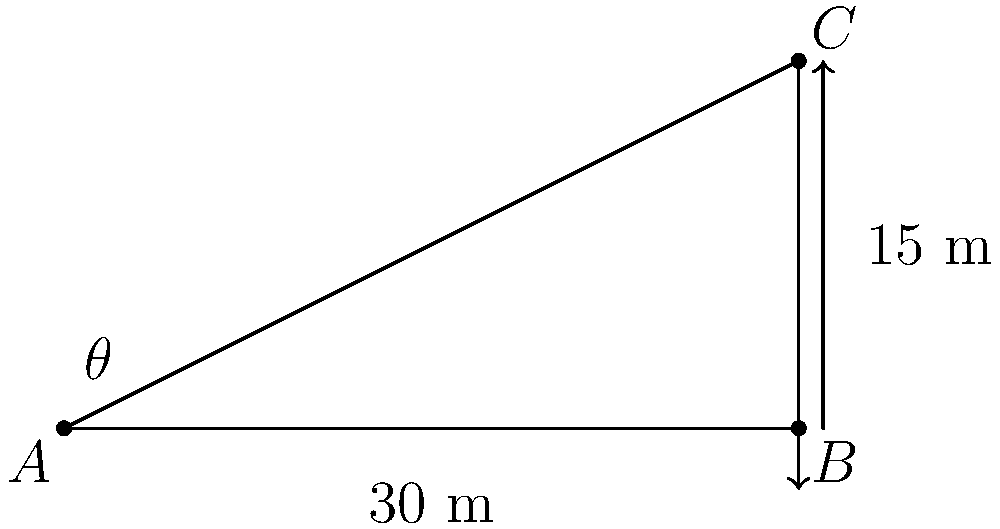As the class leader, you're organizing a field trip to study geometry in real-life situations. You've set up an experiment to measure the height of a tall building using a right triangle. From a point on the ground 30 meters away from the base of the building, you measure the angle of elevation to the top of the building to be $\theta$. If the building is 15 meters tall, what is the angle of elevation $\theta$? Let's approach this step-by-step:

1) We have a right triangle where:
   - The adjacent side (ground distance) is 30 meters
   - The opposite side (building height) is 15 meters
   - We need to find the angle $\theta$

2) In a right triangle, the tangent of an angle is the ratio of the opposite side to the adjacent side:

   $$\tan \theta = \frac{\text{opposite}}{\text{adjacent}}$$

3) Substituting our known values:

   $$\tan \theta = \frac{15}{30} = \frac{1}{2}$$

4) To find $\theta$, we need to take the inverse tangent (arctan or $\tan^{-1}$) of both sides:

   $$\theta = \tan^{-1}\left(\frac{1}{2}\right)$$

5) Using a calculator or trigonometric tables:

   $$\theta \approx 26.57^\circ$$

6) Rounding to the nearest degree:

   $$\theta \approx 27^\circ$$
Answer: $27^\circ$ 